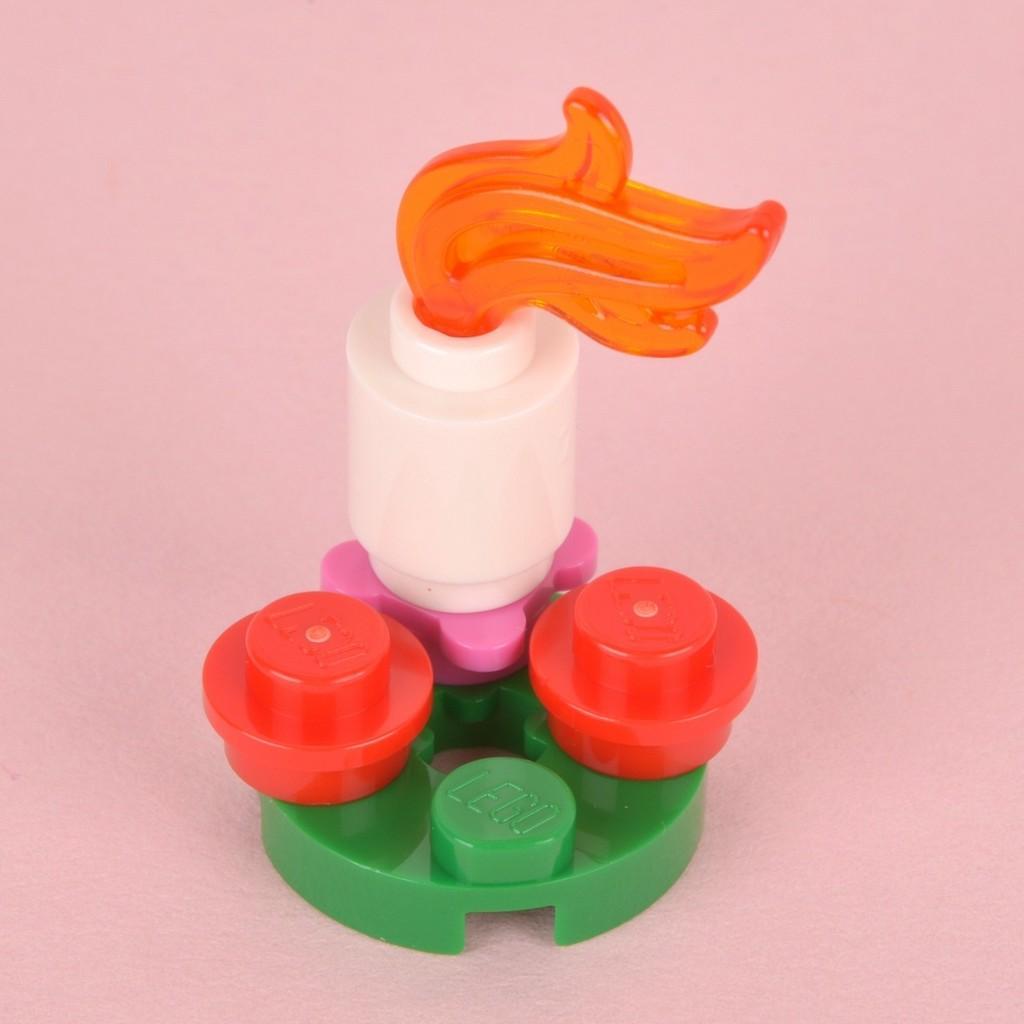Could you give a brief overview of what you see in this image? In this image we can see a toy which is placed on the surface. 